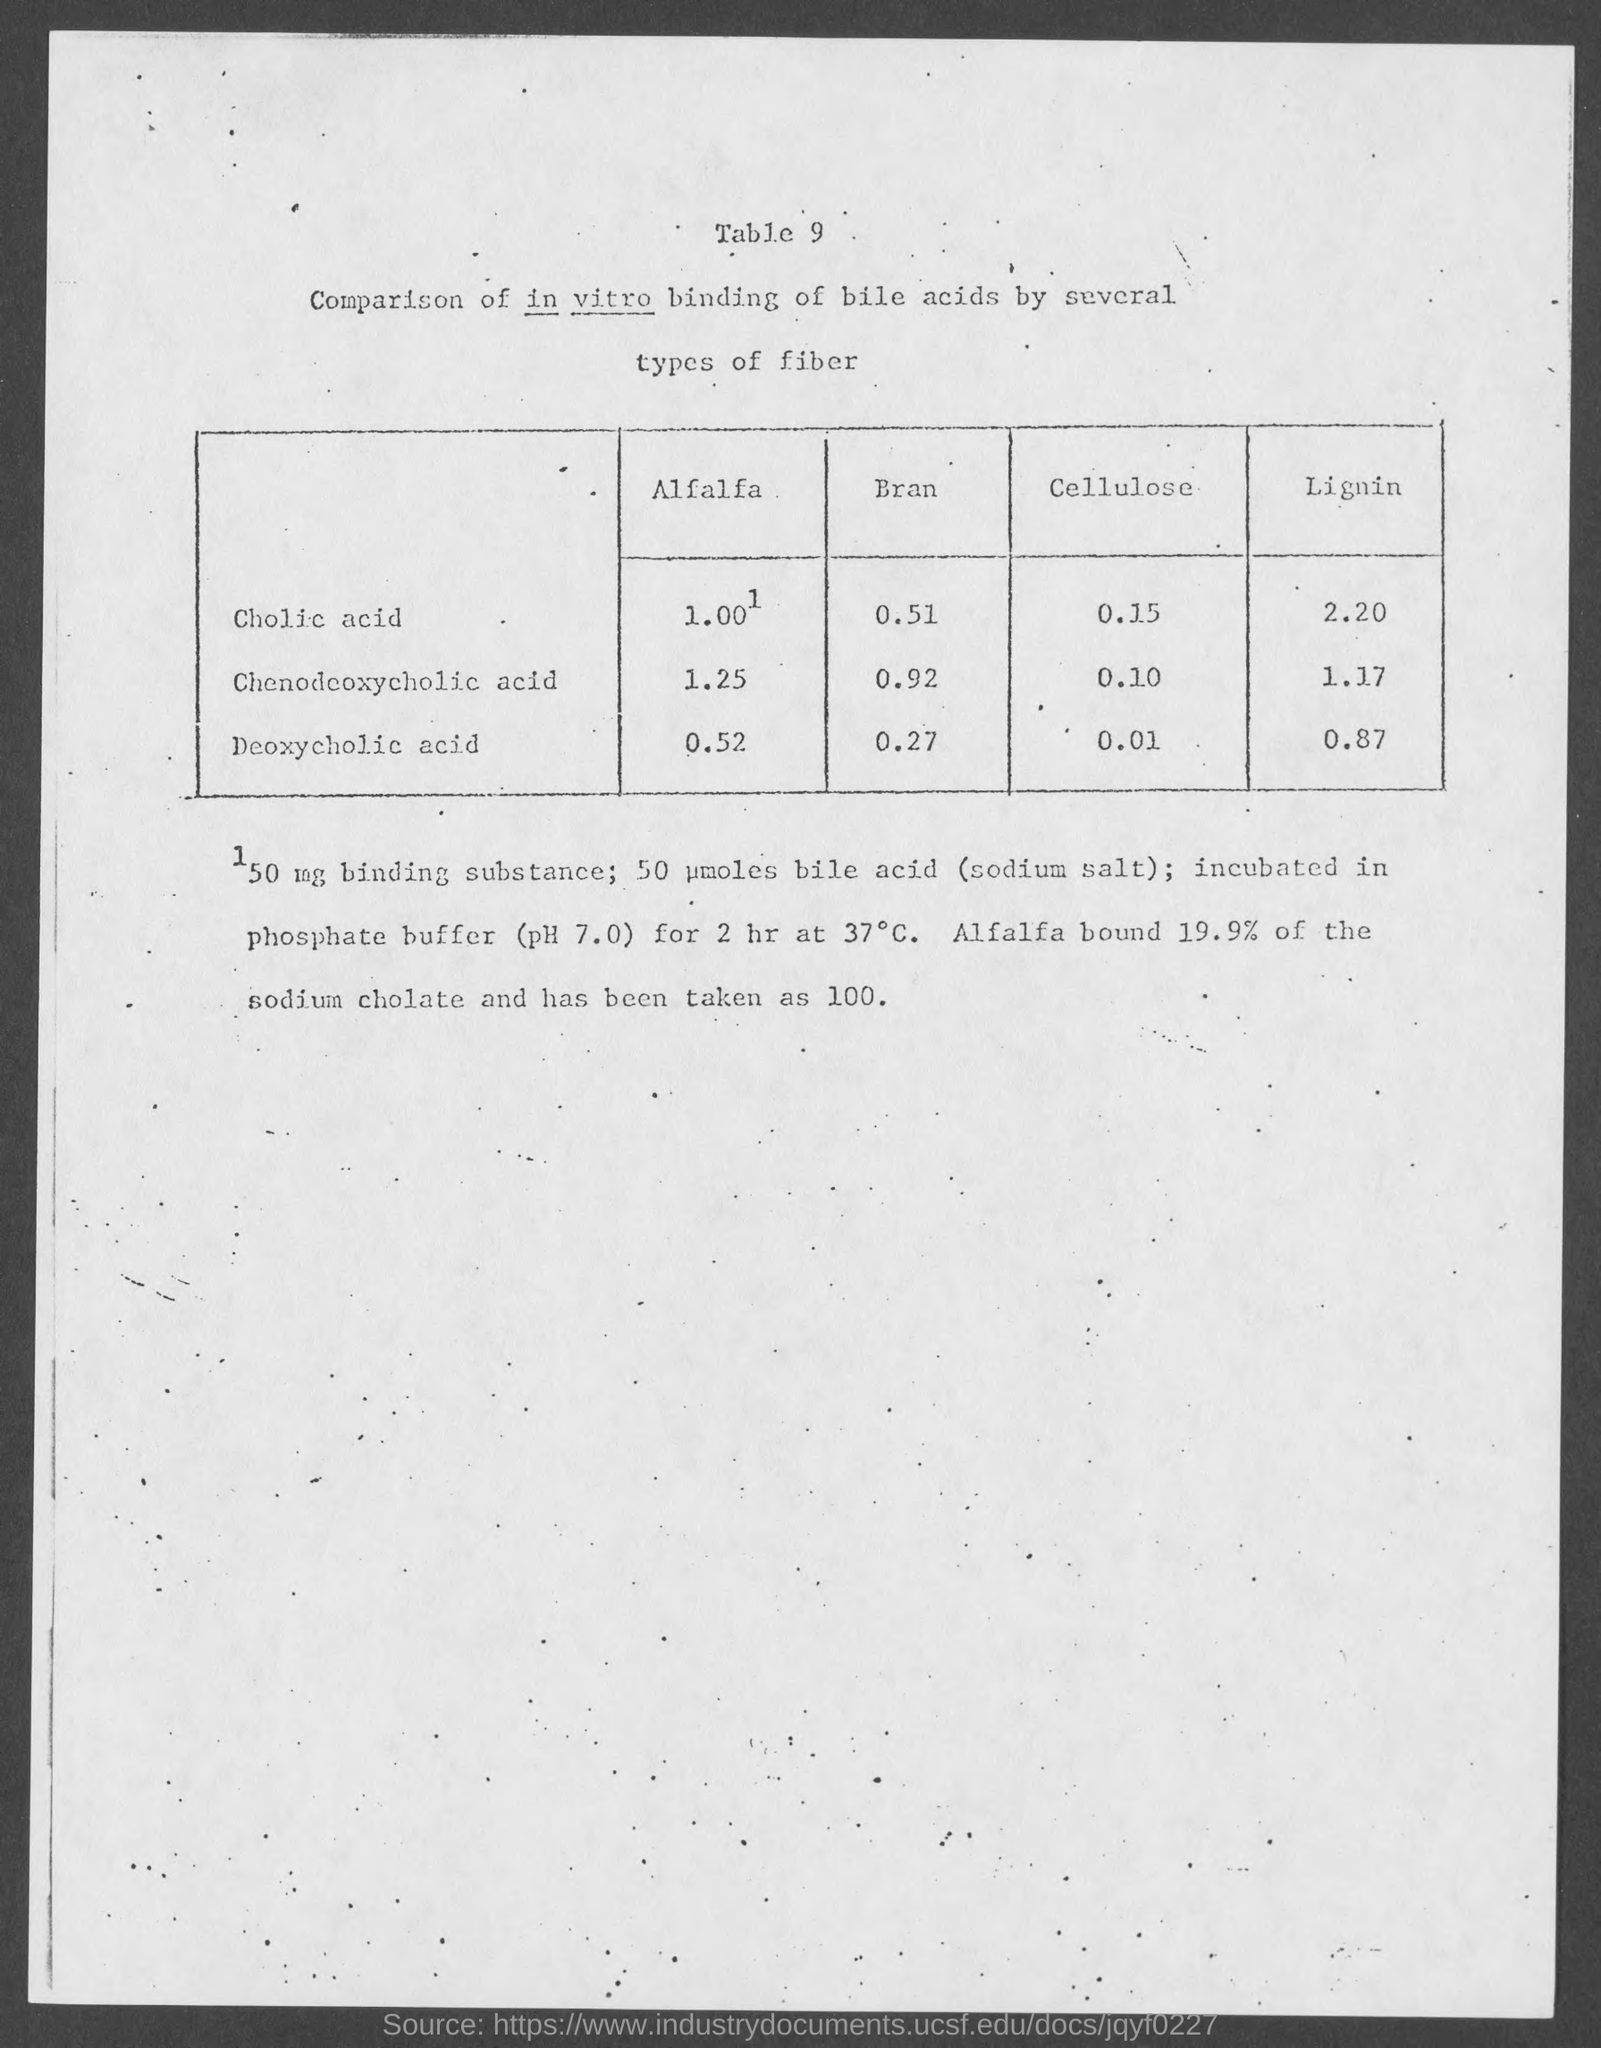What is the table number mentioned ?
Keep it short and to the point. 9. How much amount of lignin  is present in chenodeoxycholic acid
Your answer should be compact. 1.17. 